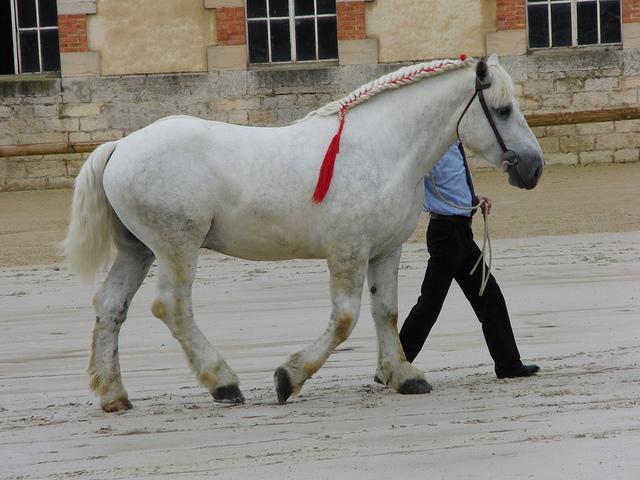How many horses are walking on the road?
Give a very brief answer. 1. How many horses are in the picture?
Give a very brief answer. 1. 